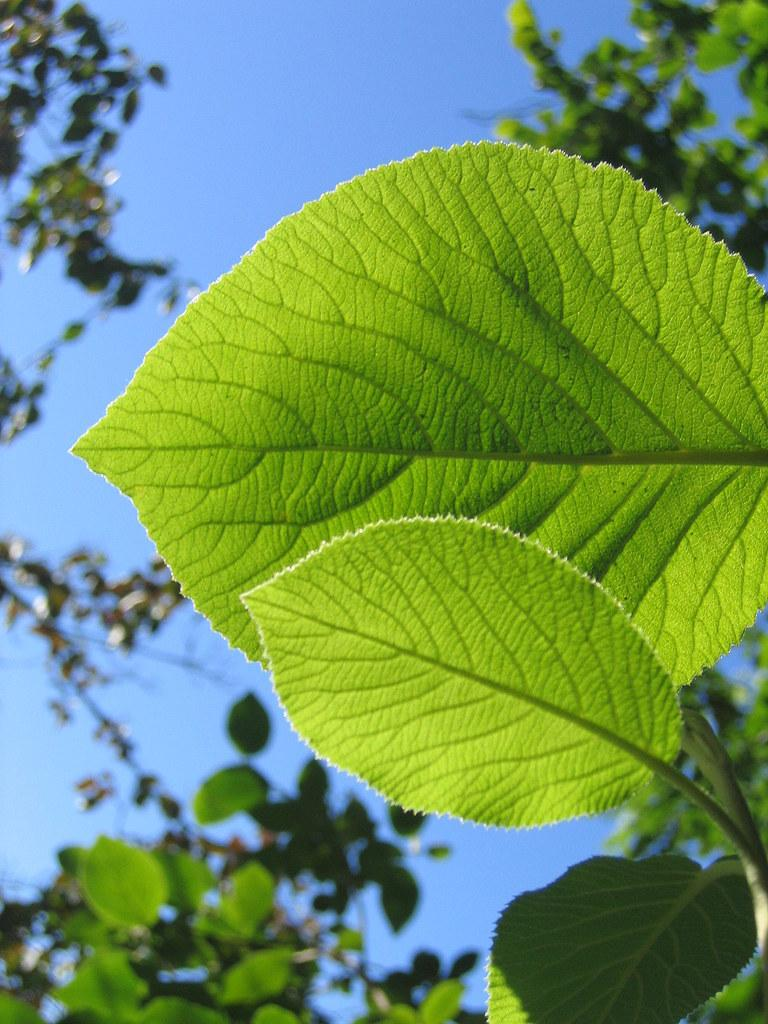What is the color of the sky in the background of the image? The sky in the background of the image is clear blue. What type of vegetation can be seen in the image? Leaves are visible in the image. Where are the green leaves located in the image? Green leaves are present on the right side of the image. What is the tendency of the leaves to copy each other's movements in the image? There is no indication in the image that the leaves are moving or copying each other's movements. 